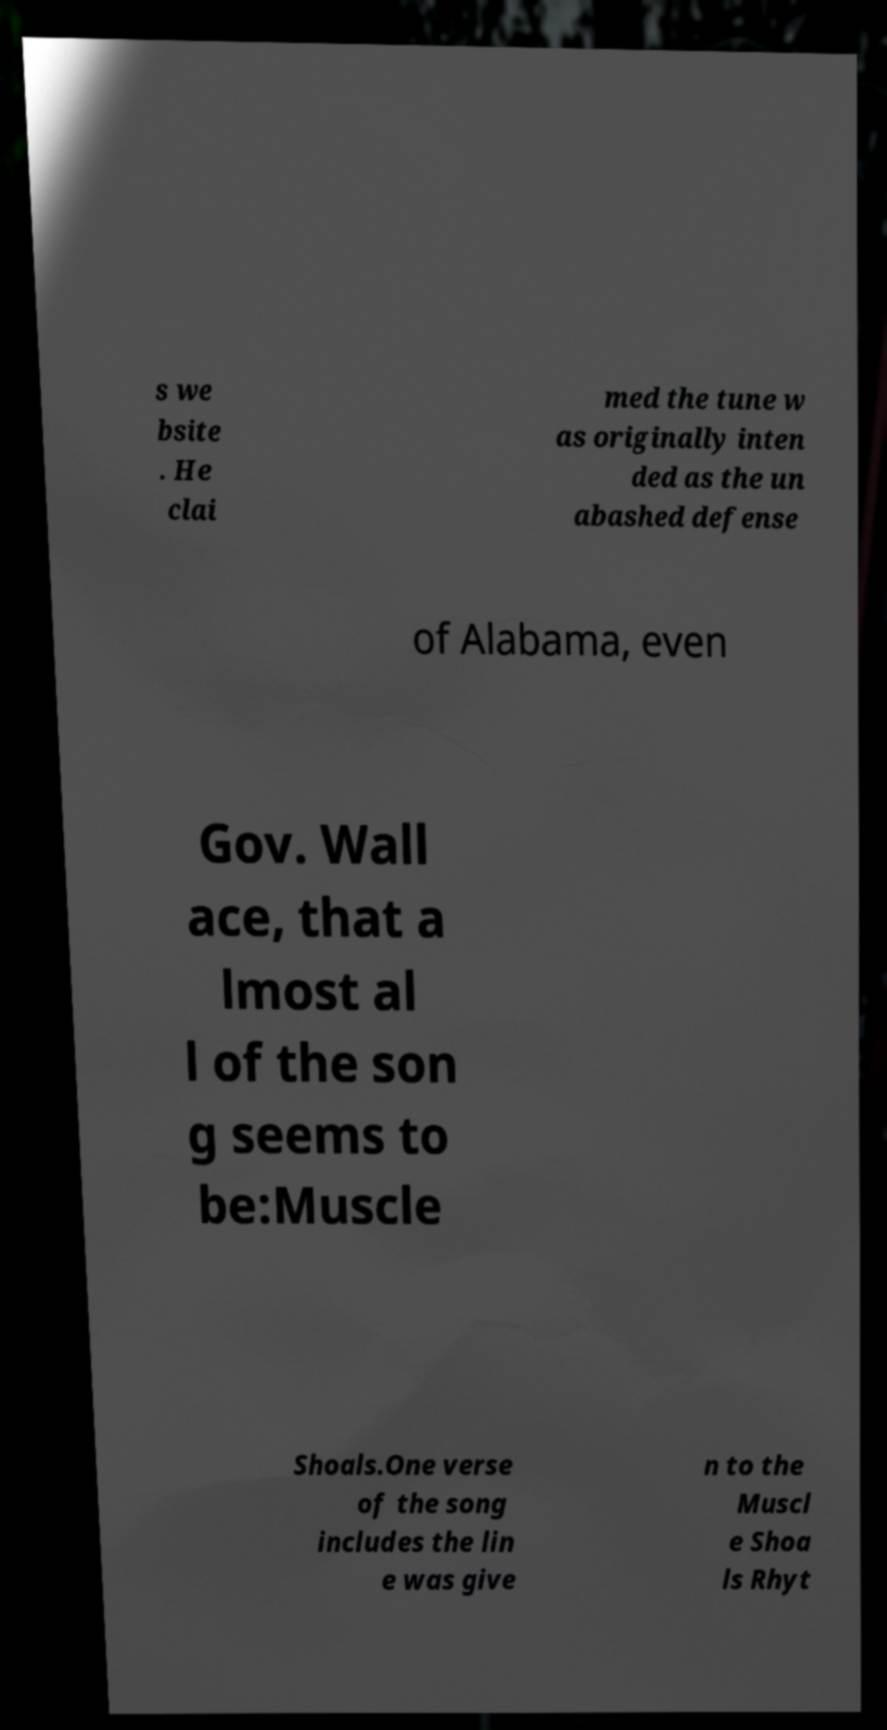Please identify and transcribe the text found in this image. s we bsite . He clai med the tune w as originally inten ded as the un abashed defense of Alabama, even Gov. Wall ace, that a lmost al l of the son g seems to be:Muscle Shoals.One verse of the song includes the lin e was give n to the Muscl e Shoa ls Rhyt 